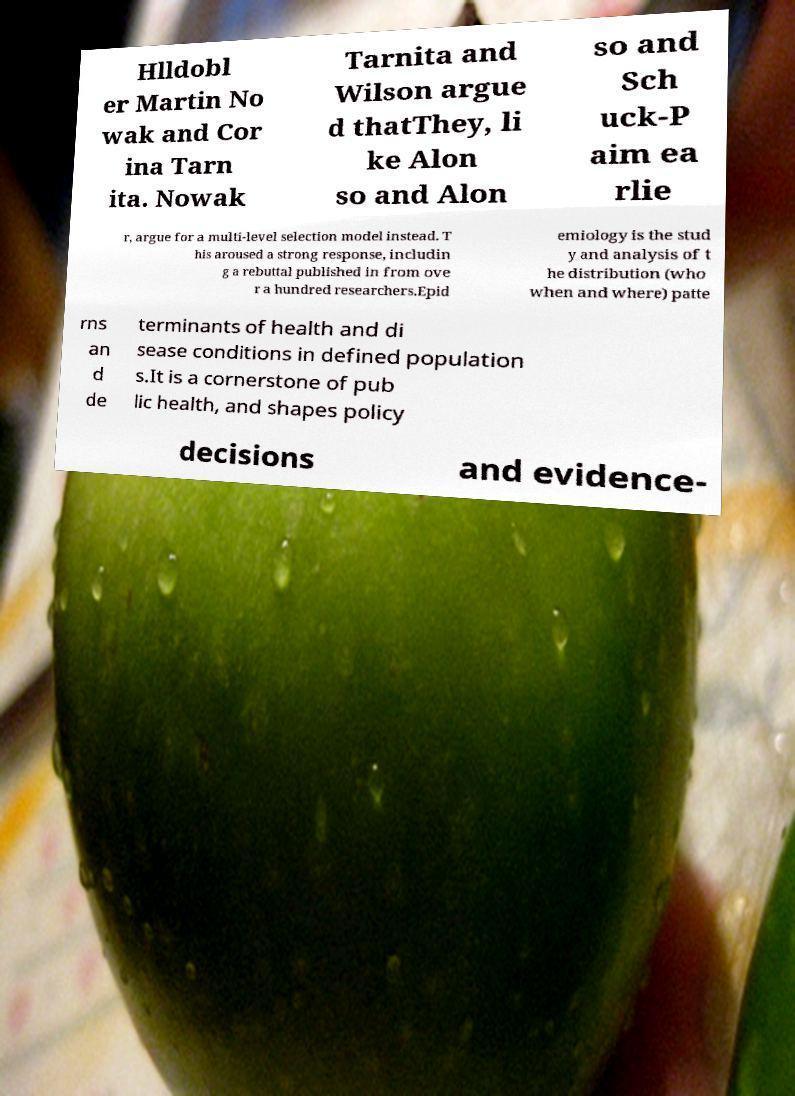Can you read and provide the text displayed in the image?This photo seems to have some interesting text. Can you extract and type it out for me? Hlldobl er Martin No wak and Cor ina Tarn ita. Nowak Tarnita and Wilson argue d thatThey, li ke Alon so and Alon so and Sch uck-P aim ea rlie r, argue for a multi-level selection model instead. T his aroused a strong response, includin g a rebuttal published in from ove r a hundred researchers.Epid emiology is the stud y and analysis of t he distribution (who when and where) patte rns an d de terminants of health and di sease conditions in defined population s.It is a cornerstone of pub lic health, and shapes policy decisions and evidence- 